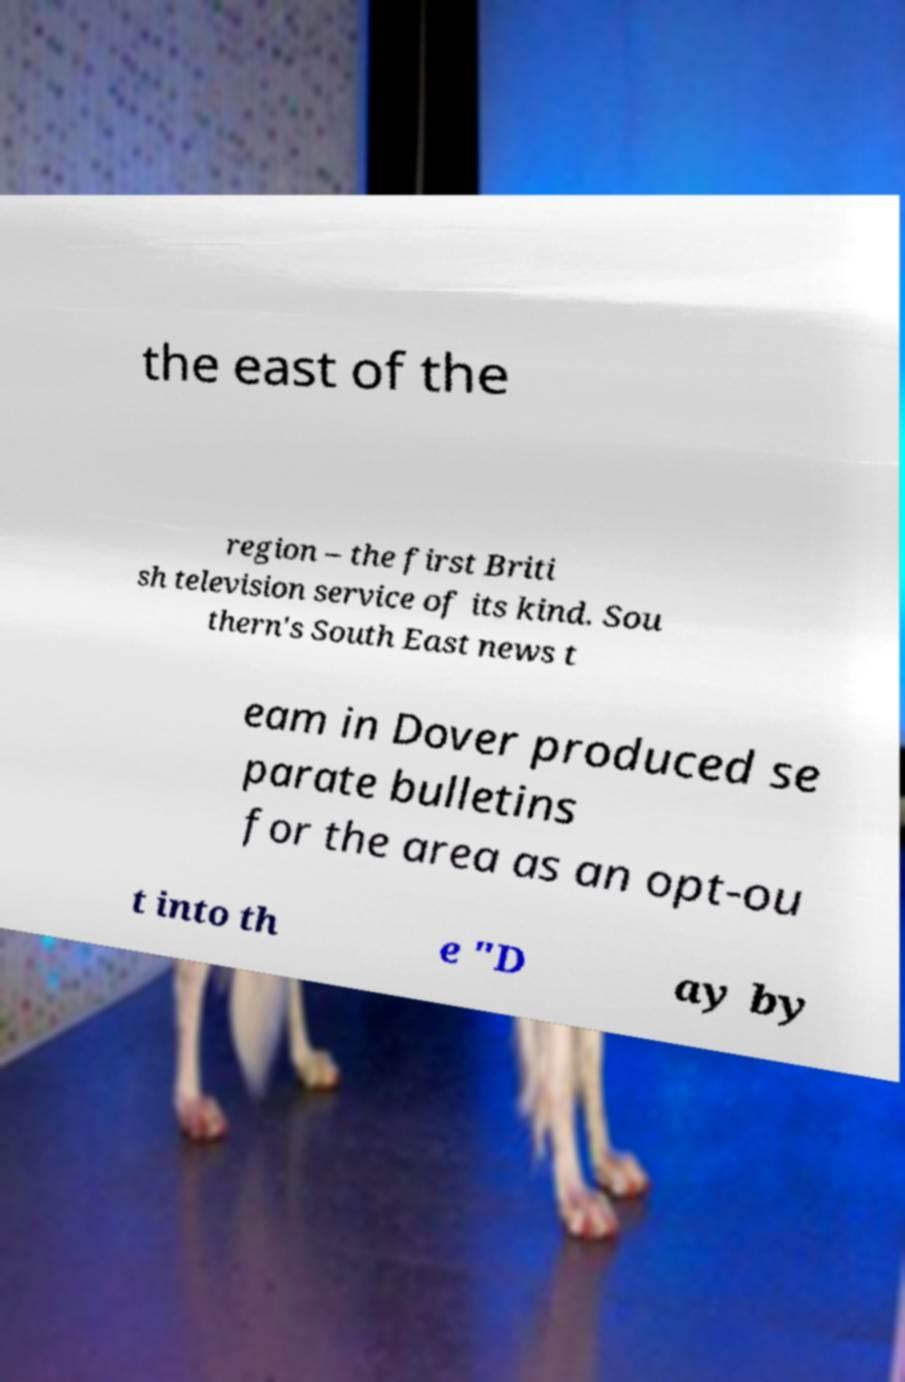I need the written content from this picture converted into text. Can you do that? the east of the region – the first Briti sh television service of its kind. Sou thern's South East news t eam in Dover produced se parate bulletins for the area as an opt-ou t into th e "D ay by 